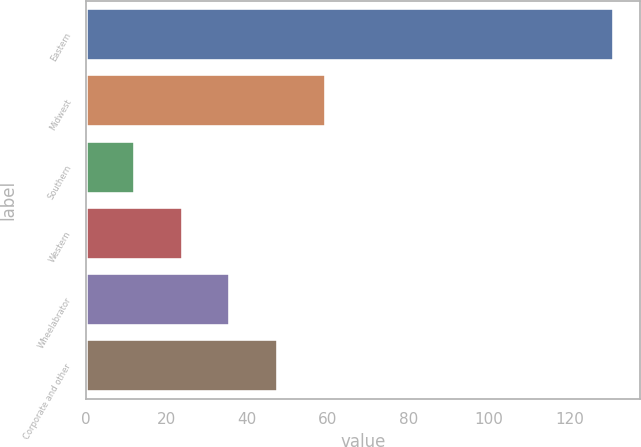Convert chart to OTSL. <chart><loc_0><loc_0><loc_500><loc_500><bar_chart><fcel>Eastern<fcel>Midwest<fcel>Southern<fcel>Western<fcel>Wheelabrator<fcel>Corporate and other<nl><fcel>131<fcel>59.6<fcel>12<fcel>23.9<fcel>35.8<fcel>47.7<nl></chart> 